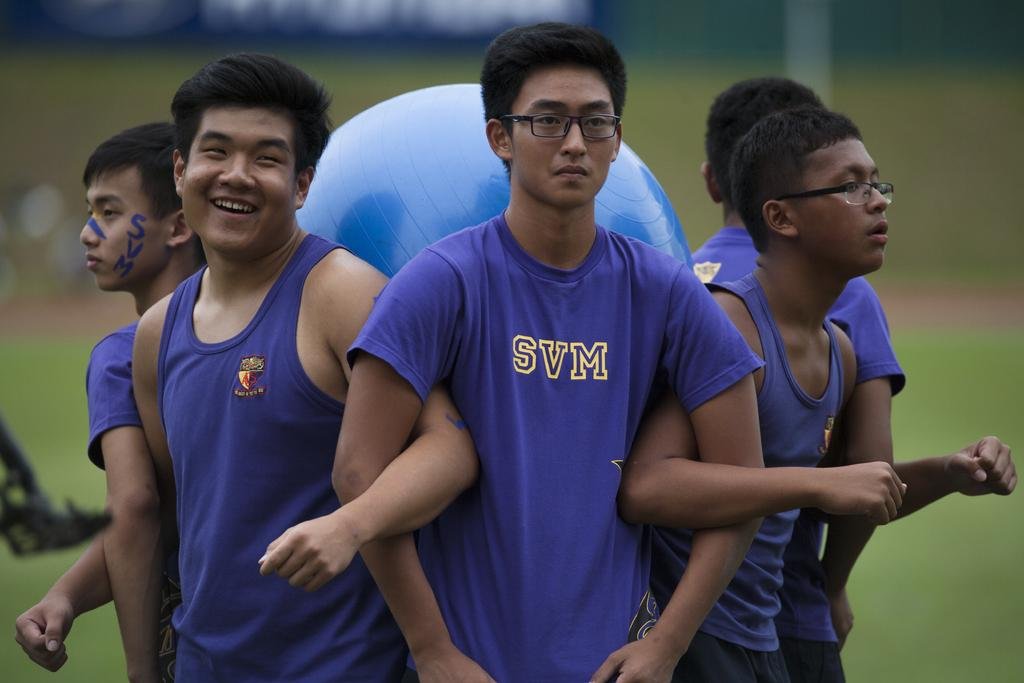What is the main subject of the image? There is a group of people in the image. What object can be seen with the group of people? There is an exercise ball in the image. Can you describe the background of the image? The background of the image is blurred. What type of spark can be seen coming from the exercise ball in the image? There is no spark present in the image; it features a group of people and an exercise ball with a blurred background. 